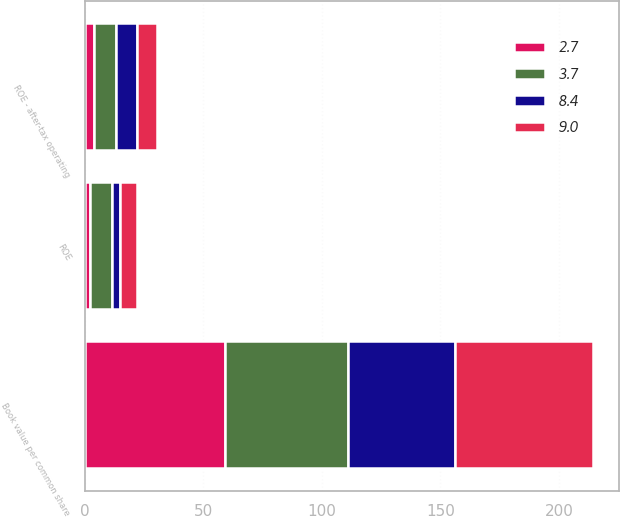Convert chart to OTSL. <chart><loc_0><loc_0><loc_500><loc_500><stacked_bar_chart><ecel><fcel>Book value per common share<fcel>ROE<fcel>ROE - after-tax operating<nl><fcel>2.7<fcel>58.94<fcel>2.2<fcel>3.7<nl><fcel>9<fcel>58.23<fcel>7.1<fcel>8.4<nl><fcel>3.7<fcel>52.12<fcel>9.2<fcel>9.3<nl><fcel>8.4<fcel>45.3<fcel>3.4<fcel>9<nl></chart> 